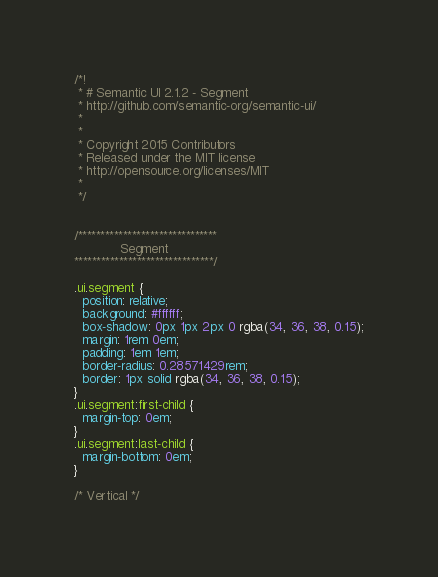Convert code to text. <code><loc_0><loc_0><loc_500><loc_500><_CSS_>/*!
 * # Semantic UI 2.1.2 - Segment
 * http://github.com/semantic-org/semantic-ui/
 *
 *
 * Copyright 2015 Contributors
 * Released under the MIT license
 * http://opensource.org/licenses/MIT
 *
 */


/*******************************
            Segment
*******************************/

.ui.segment {
  position: relative;
  background: #ffffff;
  box-shadow: 0px 1px 2px 0 rgba(34, 36, 38, 0.15);
  margin: 1rem 0em;
  padding: 1em 1em;
  border-radius: 0.28571429rem;
  border: 1px solid rgba(34, 36, 38, 0.15);
}
.ui.segment:first-child {
  margin-top: 0em;
}
.ui.segment:last-child {
  margin-bottom: 0em;
}

/* Vertical */</code> 